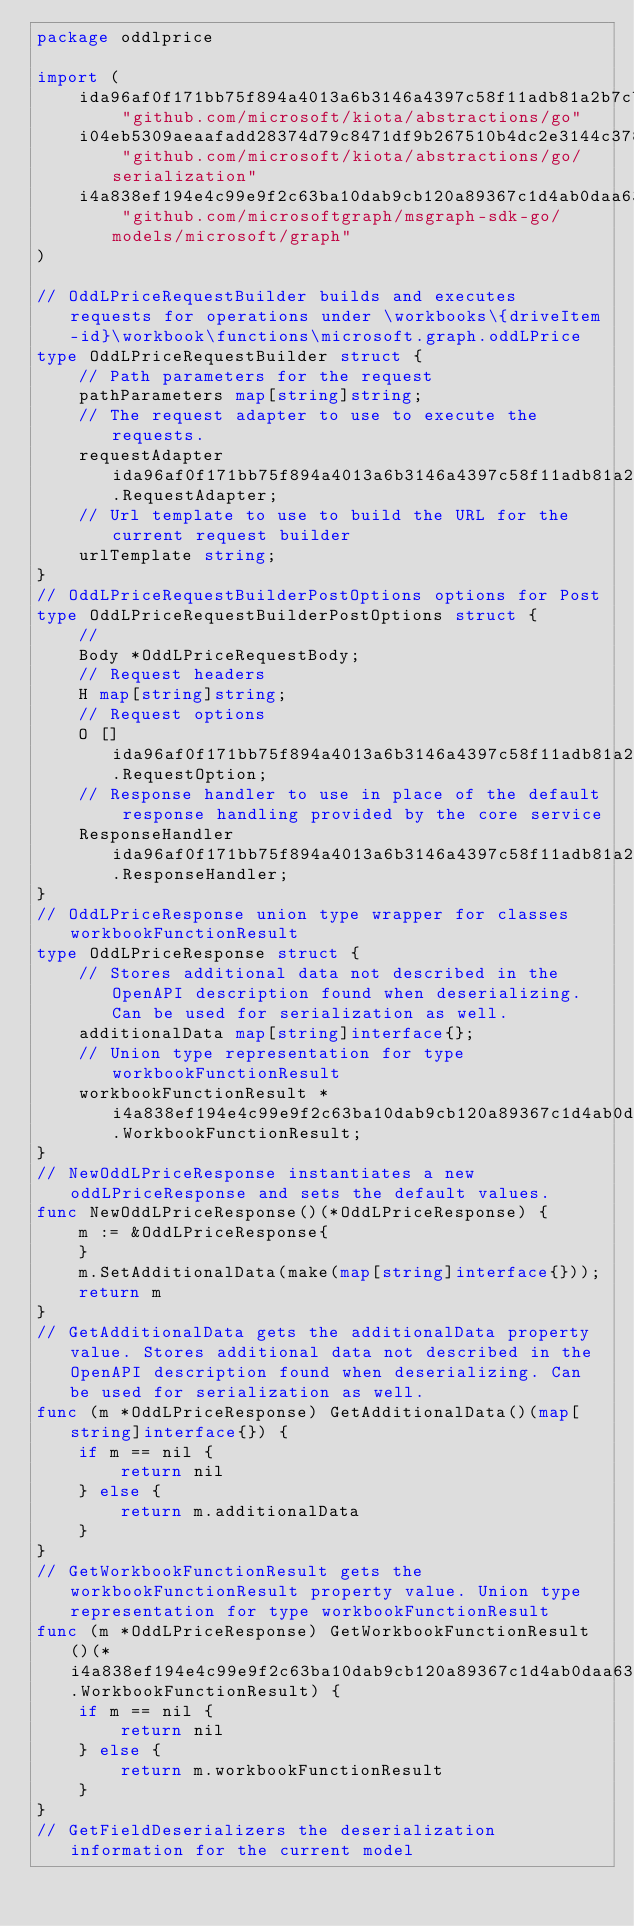Convert code to text. <code><loc_0><loc_0><loc_500><loc_500><_Go_>package oddlprice

import (
    ida96af0f171bb75f894a4013a6b3146a4397c58f11adb81a2b7cbea9314783a9 "github.com/microsoft/kiota/abstractions/go"
    i04eb5309aeaafadd28374d79c8471df9b267510b4dc2e3144c378c50f6fd7b55 "github.com/microsoft/kiota/abstractions/go/serialization"
    i4a838ef194e4c99e9f2c63ba10dab9cb120a89367c1d4ab0daa63bb424e20d87 "github.com/microsoftgraph/msgraph-sdk-go/models/microsoft/graph"
)

// OddLPriceRequestBuilder builds and executes requests for operations under \workbooks\{driveItem-id}\workbook\functions\microsoft.graph.oddLPrice
type OddLPriceRequestBuilder struct {
    // Path parameters for the request
    pathParameters map[string]string;
    // The request adapter to use to execute the requests.
    requestAdapter ida96af0f171bb75f894a4013a6b3146a4397c58f11adb81a2b7cbea9314783a9.RequestAdapter;
    // Url template to use to build the URL for the current request builder
    urlTemplate string;
}
// OddLPriceRequestBuilderPostOptions options for Post
type OddLPriceRequestBuilderPostOptions struct {
    // 
    Body *OddLPriceRequestBody;
    // Request headers
    H map[string]string;
    // Request options
    O []ida96af0f171bb75f894a4013a6b3146a4397c58f11adb81a2b7cbea9314783a9.RequestOption;
    // Response handler to use in place of the default response handling provided by the core service
    ResponseHandler ida96af0f171bb75f894a4013a6b3146a4397c58f11adb81a2b7cbea9314783a9.ResponseHandler;
}
// OddLPriceResponse union type wrapper for classes workbookFunctionResult
type OddLPriceResponse struct {
    // Stores additional data not described in the OpenAPI description found when deserializing. Can be used for serialization as well.
    additionalData map[string]interface{};
    // Union type representation for type workbookFunctionResult
    workbookFunctionResult *i4a838ef194e4c99e9f2c63ba10dab9cb120a89367c1d4ab0daa63bb424e20d87.WorkbookFunctionResult;
}
// NewOddLPriceResponse instantiates a new oddLPriceResponse and sets the default values.
func NewOddLPriceResponse()(*OddLPriceResponse) {
    m := &OddLPriceResponse{
    }
    m.SetAdditionalData(make(map[string]interface{}));
    return m
}
// GetAdditionalData gets the additionalData property value. Stores additional data not described in the OpenAPI description found when deserializing. Can be used for serialization as well.
func (m *OddLPriceResponse) GetAdditionalData()(map[string]interface{}) {
    if m == nil {
        return nil
    } else {
        return m.additionalData
    }
}
// GetWorkbookFunctionResult gets the workbookFunctionResult property value. Union type representation for type workbookFunctionResult
func (m *OddLPriceResponse) GetWorkbookFunctionResult()(*i4a838ef194e4c99e9f2c63ba10dab9cb120a89367c1d4ab0daa63bb424e20d87.WorkbookFunctionResult) {
    if m == nil {
        return nil
    } else {
        return m.workbookFunctionResult
    }
}
// GetFieldDeserializers the deserialization information for the current model</code> 